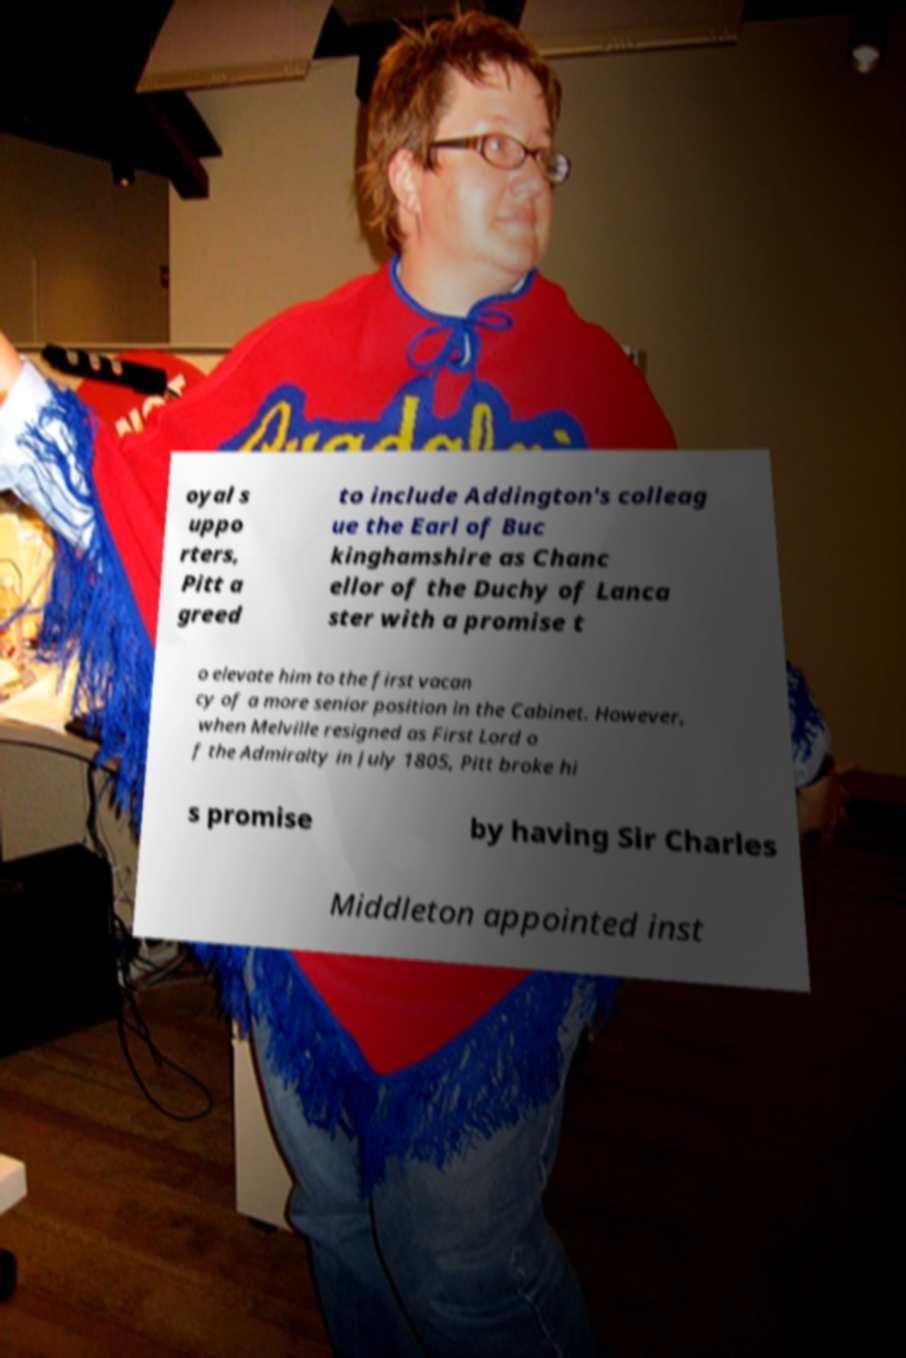Could you assist in decoding the text presented in this image and type it out clearly? oyal s uppo rters, Pitt a greed to include Addington's colleag ue the Earl of Buc kinghamshire as Chanc ellor of the Duchy of Lanca ster with a promise t o elevate him to the first vacan cy of a more senior position in the Cabinet. However, when Melville resigned as First Lord o f the Admiralty in July 1805, Pitt broke hi s promise by having Sir Charles Middleton appointed inst 